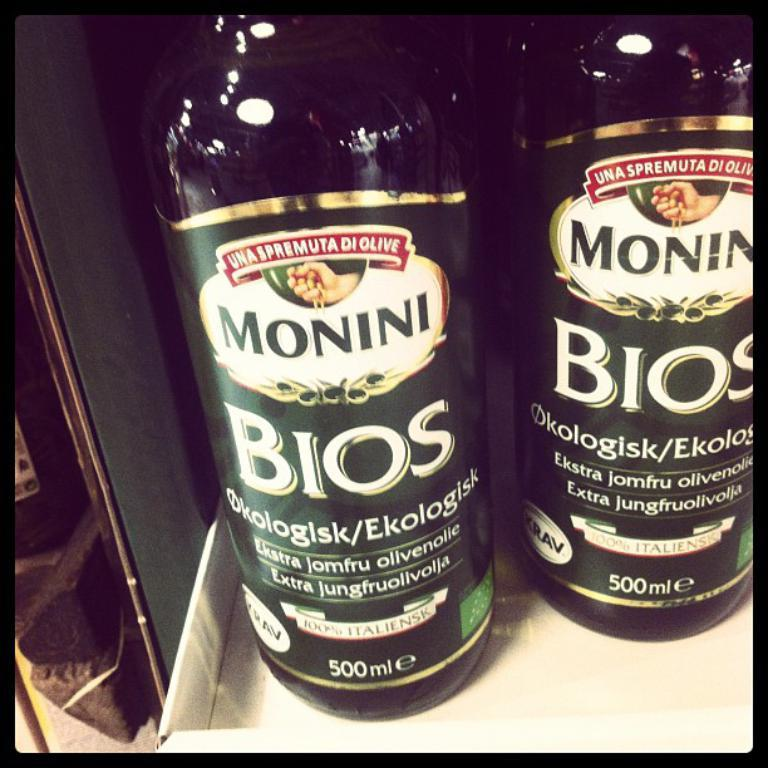<image>
Describe the image concisely. Black bottle with a label that says "BIOS" on it. 